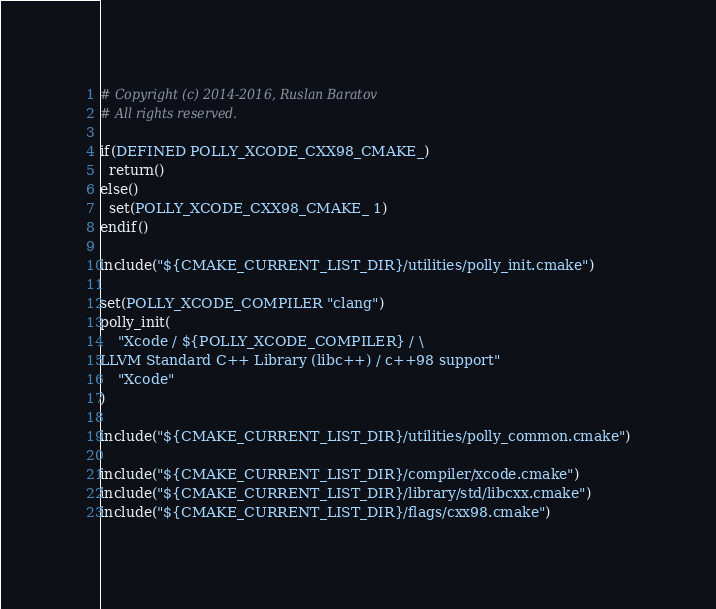Convert code to text. <code><loc_0><loc_0><loc_500><loc_500><_CMake_># Copyright (c) 2014-2016, Ruslan Baratov
# All rights reserved.

if(DEFINED POLLY_XCODE_CXX98_CMAKE_)
  return()
else()
  set(POLLY_XCODE_CXX98_CMAKE_ 1)
endif()

include("${CMAKE_CURRENT_LIST_DIR}/utilities/polly_init.cmake")

set(POLLY_XCODE_COMPILER "clang")
polly_init(
    "Xcode / ${POLLY_XCODE_COMPILER} / \
LLVM Standard C++ Library (libc++) / c++98 support"
    "Xcode"
)

include("${CMAKE_CURRENT_LIST_DIR}/utilities/polly_common.cmake")

include("${CMAKE_CURRENT_LIST_DIR}/compiler/xcode.cmake")
include("${CMAKE_CURRENT_LIST_DIR}/library/std/libcxx.cmake")
include("${CMAKE_CURRENT_LIST_DIR}/flags/cxx98.cmake")
</code> 